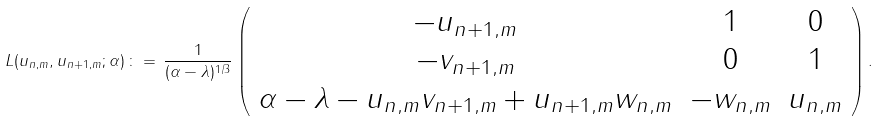<formula> <loc_0><loc_0><loc_500><loc_500>L ( { u } _ { n , m } , { u } _ { n + 1 , m } ; \alpha ) \, \colon = \, \frac { 1 } { ( \alpha - \lambda ) ^ { 1 / 3 } } \left ( \begin{array} { c c c } - u _ { n + 1 , m } & 1 & 0 \\ - v _ { n + 1 , m } & 0 & 1 \\ \alpha - \lambda - u _ { n , m } v _ { n + 1 , m } + u _ { n + 1 , m } w _ { n , m } & - w _ { n , m } & u _ { n , m } \end{array} \right ) .</formula> 